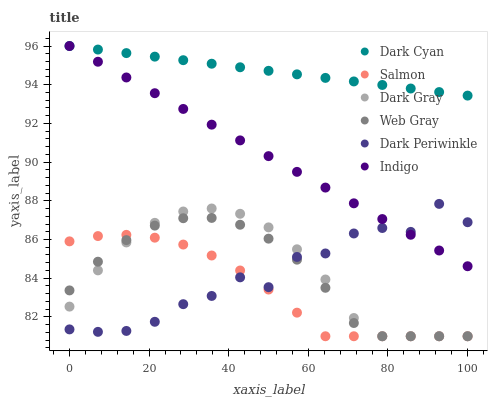Does Salmon have the minimum area under the curve?
Answer yes or no. Yes. Does Dark Cyan have the maximum area under the curve?
Answer yes or no. Yes. Does Indigo have the minimum area under the curve?
Answer yes or no. No. Does Indigo have the maximum area under the curve?
Answer yes or no. No. Is Dark Cyan the smoothest?
Answer yes or no. Yes. Is Dark Periwinkle the roughest?
Answer yes or no. Yes. Is Indigo the smoothest?
Answer yes or no. No. Is Indigo the roughest?
Answer yes or no. No. Does Web Gray have the lowest value?
Answer yes or no. Yes. Does Indigo have the lowest value?
Answer yes or no. No. Does Dark Cyan have the highest value?
Answer yes or no. Yes. Does Salmon have the highest value?
Answer yes or no. No. Is Salmon less than Indigo?
Answer yes or no. Yes. Is Dark Cyan greater than Web Gray?
Answer yes or no. Yes. Does Dark Periwinkle intersect Salmon?
Answer yes or no. Yes. Is Dark Periwinkle less than Salmon?
Answer yes or no. No. Is Dark Periwinkle greater than Salmon?
Answer yes or no. No. Does Salmon intersect Indigo?
Answer yes or no. No. 